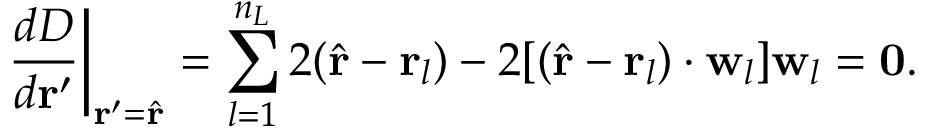Convert formula to latex. <formula><loc_0><loc_0><loc_500><loc_500>\frac { d D } { d r ^ { \prime } } \Big | _ { r ^ { \prime } = \hat { r } } = \sum _ { l = 1 } ^ { n _ { L } } 2 ( \hat { r } - r _ { l } ) - 2 [ ( \hat { r } - r _ { l } ) \cdot w _ { l } ] w _ { l } = 0 .</formula> 